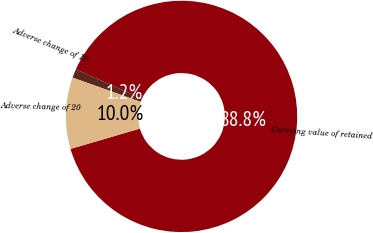Convert chart to OTSL. <chart><loc_0><loc_0><loc_500><loc_500><pie_chart><fcel>Carrying value of retained<fcel>Adverse change of 10<fcel>Adverse change of 20<nl><fcel>88.79%<fcel>1.23%<fcel>9.98%<nl></chart> 